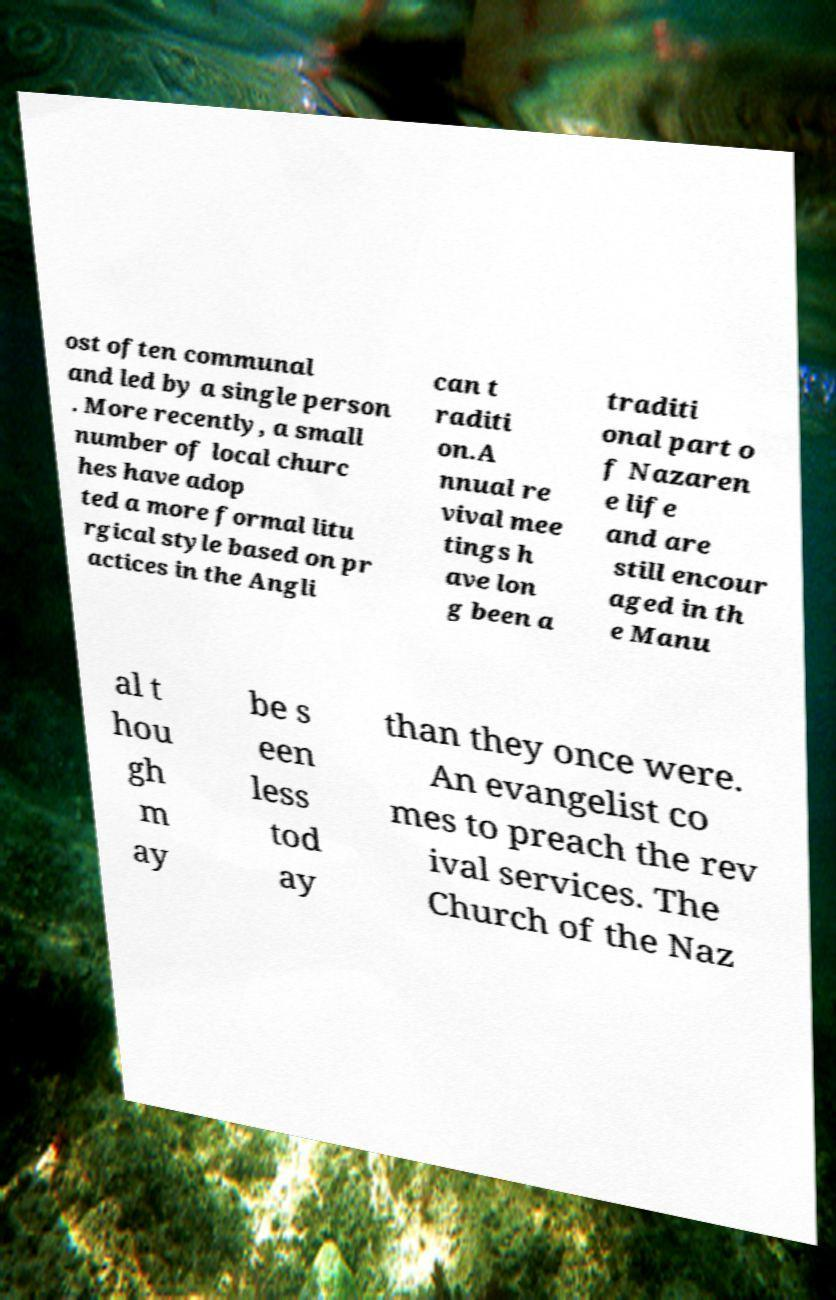Could you assist in decoding the text presented in this image and type it out clearly? ost often communal and led by a single person . More recently, a small number of local churc hes have adop ted a more formal litu rgical style based on pr actices in the Angli can t raditi on.A nnual re vival mee tings h ave lon g been a traditi onal part o f Nazaren e life and are still encour aged in th e Manu al t hou gh m ay be s een less tod ay than they once were. An evangelist co mes to preach the rev ival services. The Church of the Naz 